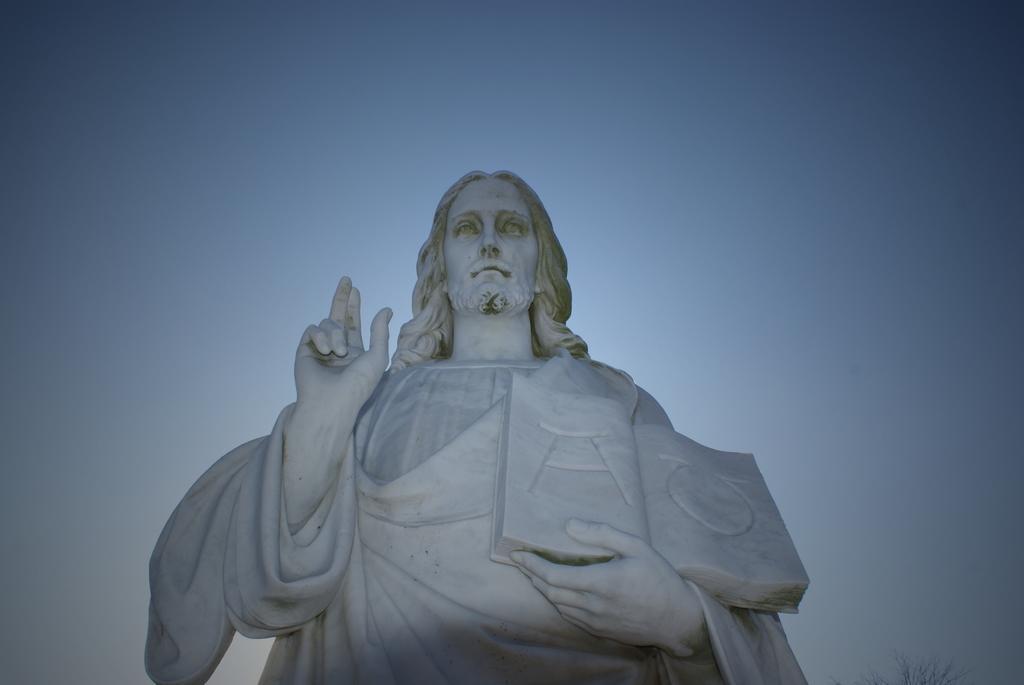In one or two sentences, can you explain what this image depicts? In this image, we can see a sculpture. 